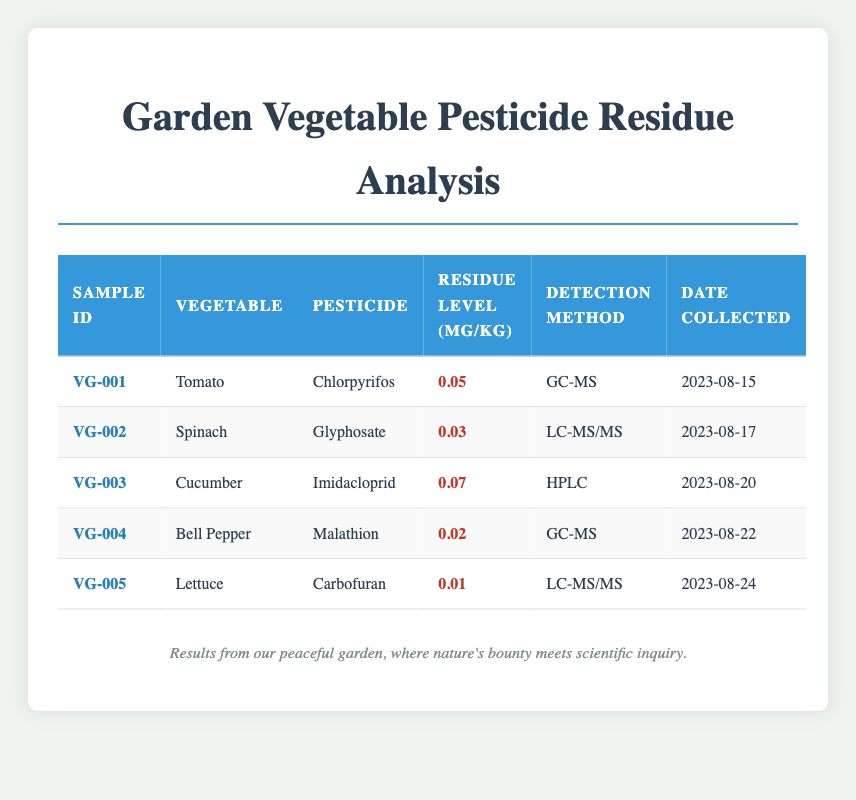What is the residue level of Chlorpyrifos in tomatoes? The table shows that the sample for tomatoes (VG-001) has a residue level of 0.05 mg/kg for Chlorpyrifos.
Answer: 0.05 mg/kg Which vegetable has the highest pesticide residue level? By reviewing the "Residue Level" column, the cucumber (VG-003) has the highest residue level at 0.07 mg/kg.
Answer: Cucumber (0.07 mg/kg) Is there any vegetable with a pesticide residue level below 0.02 mg/kg? Yes, the lettuce (VG-005) has a residue level of 0.01 mg/kg, which is below 0.02 mg/kg.
Answer: Yes What is the average residue level of pesticides for all the samples? To find the average, we sum the residue levels: 0.05 + 0.03 + 0.07 + 0.02 + 0.01 = 0.18 mg/kg. There are 5 samples, so 0.18/5 = 0.036 mg/kg is the average residue level.
Answer: 0.036 mg/kg Which pesticide was detected in the bell pepper? According to the table, the bell pepper (VG-004) has a pesticide detection of Malathion.
Answer: Malathion Is the detection method for Glyphosate the same as for Carbofuran? The table shows that Glyphosate is detected using LC-MS/MS, while Carbofuran is detected using LC-MS/MS as well, confirming they use the same method.
Answer: Yes How many vegetables have pesticide residue levels above 0.04 mg/kg? After reviewing the residue levels, only the cucumber (0.07 mg/kg) exceeds 0.04 mg/kg, so there is only one vegetable that meets this criterion.
Answer: 1 What is the pesticide residue level of Spinach? The table indicates that Spinach (VG-002) has a residue level of 0.03 mg/kg for Glyphosate.
Answer: 0.03 mg/kg Which vegetable has the lowest pesticide residue level and what is it? The lettuce (VG-005) has the lowest residue level at 0.01 mg/kg, which is lower than all other detected levels.
Answer: Lettuce (0.01 mg/kg) 